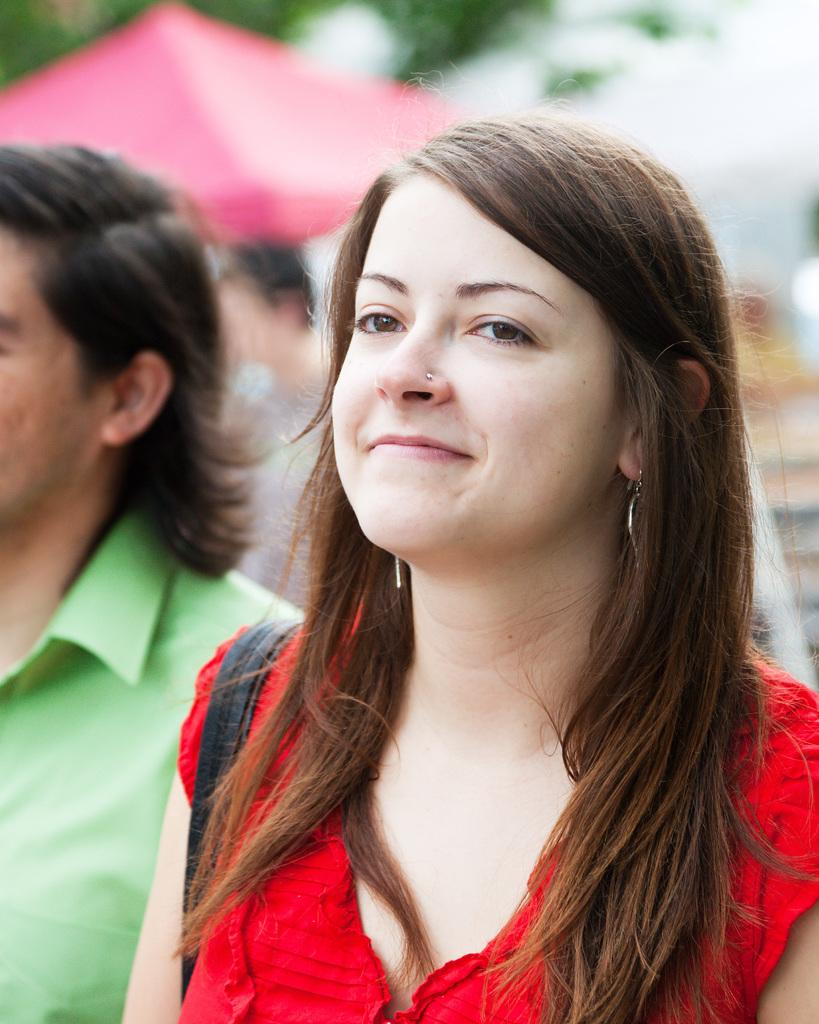Who is the main subject in the foreground of the image? There is a woman in the foreground of the image. What is the woman wearing? The woman is wearing a red dress and a bag. Who is the other person in the foreground of the image? There is a man in the foreground of the image. What is the man wearing? The man is wearing a green shirt. How would you describe the background of the image? The background of the image is blurred. Can you see any flies buzzing around the woman's head in the image? There are no flies visible in the image. What part of the brain can be seen in the image? There is no brain visible in the image; it features a woman and a man in the foreground. 